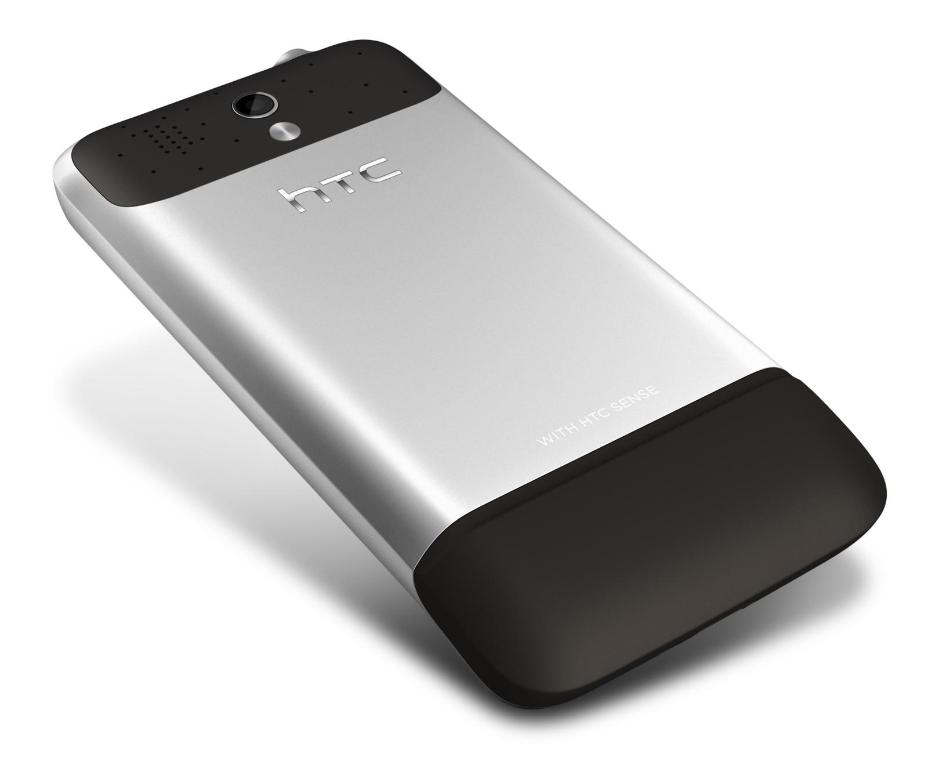Provide a one-sentence caption for the provided image. A sleek HTC smartphone featuring a distinctive two-tone design with a silver and black exterior, a rear camera, and microphone holes on a plain white background. 